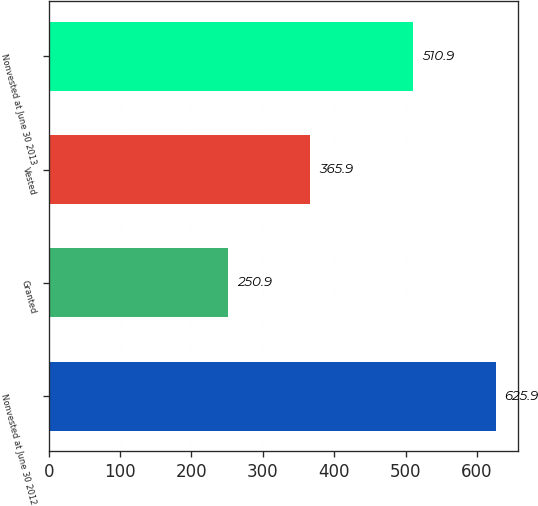Convert chart. <chart><loc_0><loc_0><loc_500><loc_500><bar_chart><fcel>Nonvested at June 30 2012<fcel>Granted<fcel>Vested<fcel>Nonvested at June 30 2013<nl><fcel>625.9<fcel>250.9<fcel>365.9<fcel>510.9<nl></chart> 